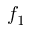Convert formula to latex. <formula><loc_0><loc_0><loc_500><loc_500>f _ { 1 }</formula> 